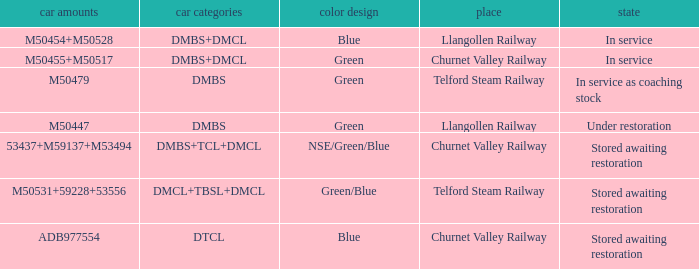What livery has a status of in service as coaching stock? Green. 